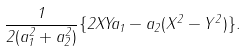<formula> <loc_0><loc_0><loc_500><loc_500>\frac { 1 } { 2 ( a _ { 1 } ^ { 2 } + a _ { 2 } ^ { 2 } ) } \{ 2 X Y a _ { 1 } - a _ { 2 } ( X ^ { 2 } - Y ^ { 2 } ) \} .</formula> 